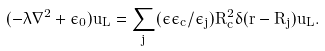Convert formula to latex. <formula><loc_0><loc_0><loc_500><loc_500>( - \lambda \nabla ^ { 2 } + \epsilon _ { 0 } ) u _ { L } = \sum _ { j } ( { \epsilon \epsilon _ { c } } / { \epsilon _ { j } } ) R _ { c } ^ { 2 } \delta ( { r } - { R } _ { j } ) u _ { L } .</formula> 